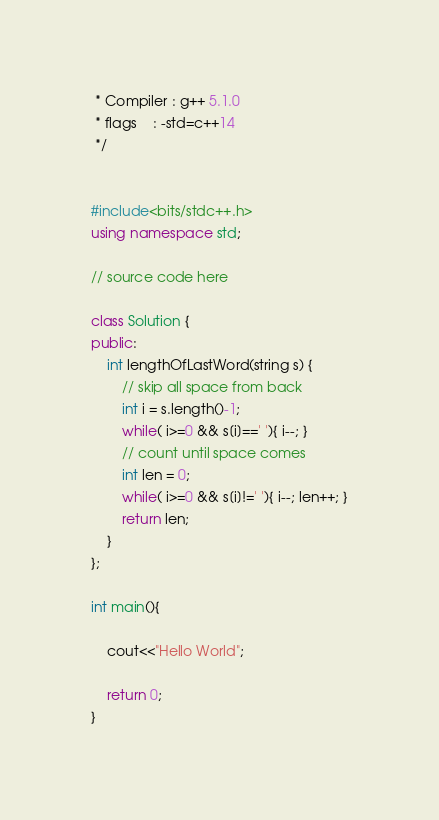Convert code to text. <code><loc_0><loc_0><loc_500><loc_500><_C++_> * Compiler : g++ 5.1.0
 * flags    : -std=c++14
 */


#include<bits/stdc++.h>
using namespace std;

// source code here

class Solution {
public:
    int lengthOfLastWord(string s) {
        // skip all space from back
        int i = s.length()-1;
        while( i>=0 && s[i]==' '){ i--; }
        // count until space comes
        int len = 0;
        while( i>=0 && s[i]!=' '){ i--; len++; }
        return len;
    }
};

int main(){

	cout<<"Hello World";

    return 0;
}

</code> 